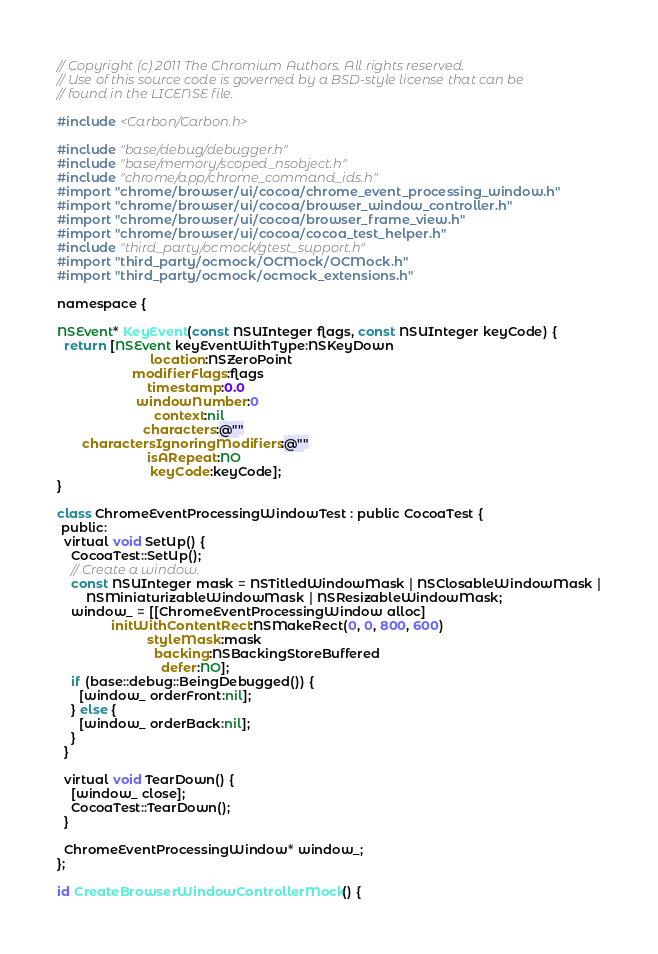Convert code to text. <code><loc_0><loc_0><loc_500><loc_500><_ObjectiveC_>// Copyright (c) 2011 The Chromium Authors. All rights reserved.
// Use of this source code is governed by a BSD-style license that can be
// found in the LICENSE file.

#include <Carbon/Carbon.h>

#include "base/debug/debugger.h"
#include "base/memory/scoped_nsobject.h"
#include "chrome/app/chrome_command_ids.h"
#import "chrome/browser/ui/cocoa/chrome_event_processing_window.h"
#import "chrome/browser/ui/cocoa/browser_window_controller.h"
#import "chrome/browser/ui/cocoa/browser_frame_view.h"
#import "chrome/browser/ui/cocoa/cocoa_test_helper.h"
#include "third_party/ocmock/gtest_support.h"
#import "third_party/ocmock/OCMock/OCMock.h"
#import "third_party/ocmock/ocmock_extensions.h"

namespace {

NSEvent* KeyEvent(const NSUInteger flags, const NSUInteger keyCode) {
  return [NSEvent keyEventWithType:NSKeyDown
                          location:NSZeroPoint
                     modifierFlags:flags
                         timestamp:0.0
                      windowNumber:0
                           context:nil
                        characters:@""
       charactersIgnoringModifiers:@""
                         isARepeat:NO
                          keyCode:keyCode];
}

class ChromeEventProcessingWindowTest : public CocoaTest {
 public:
  virtual void SetUp() {
    CocoaTest::SetUp();
    // Create a window.
    const NSUInteger mask = NSTitledWindowMask | NSClosableWindowMask |
        NSMiniaturizableWindowMask | NSResizableWindowMask;
    window_ = [[ChromeEventProcessingWindow alloc]
               initWithContentRect:NSMakeRect(0, 0, 800, 600)
                         styleMask:mask
                           backing:NSBackingStoreBuffered
                             defer:NO];
    if (base::debug::BeingDebugged()) {
      [window_ orderFront:nil];
    } else {
      [window_ orderBack:nil];
    }
  }

  virtual void TearDown() {
    [window_ close];
    CocoaTest::TearDown();
  }

  ChromeEventProcessingWindow* window_;
};

id CreateBrowserWindowControllerMock() {</code> 